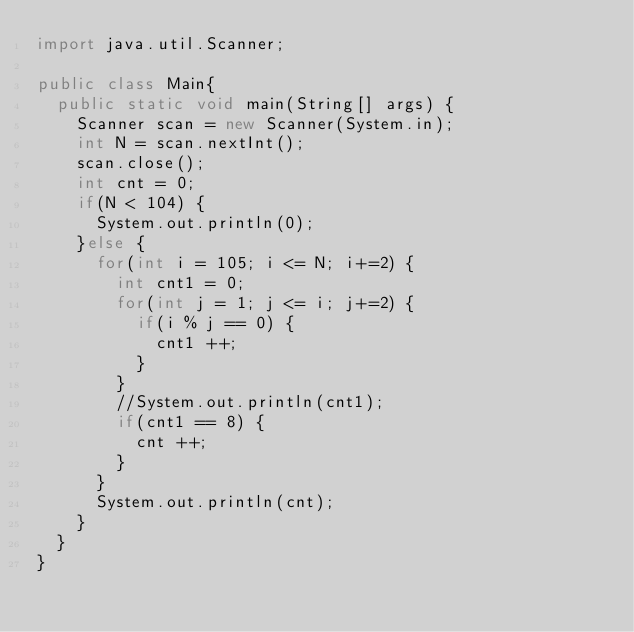Convert code to text. <code><loc_0><loc_0><loc_500><loc_500><_Java_>import java.util.Scanner;

public class Main{
	public static void main(String[] args) {
		Scanner scan = new Scanner(System.in);
		int N = scan.nextInt();
		scan.close();
		int cnt = 0;
		if(N < 104) {
			System.out.println(0);
		}else {
			for(int i = 105; i <= N; i+=2) {
				int cnt1 = 0;
				for(int j = 1; j <= i; j+=2) {
					if(i % j == 0) {
						cnt1 ++;
					}
				}
				//System.out.println(cnt1);
				if(cnt1 == 8) {
					cnt ++;
				}
			}
			System.out.println(cnt);
		}
	}
}</code> 